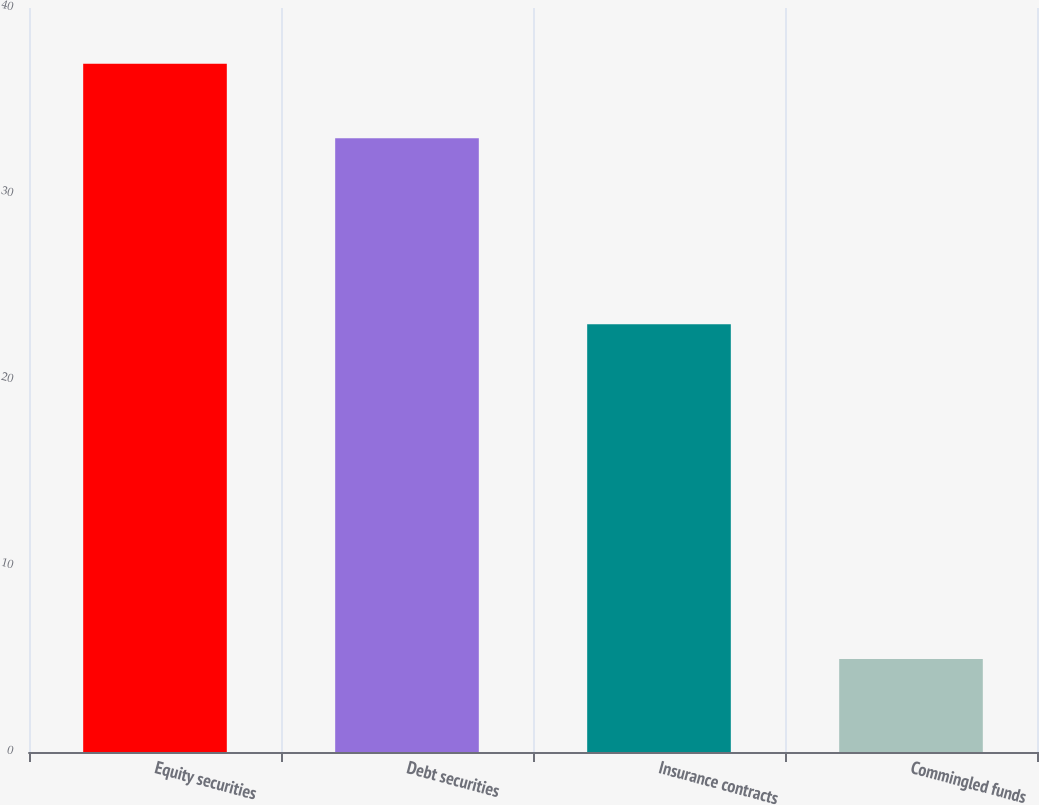Convert chart to OTSL. <chart><loc_0><loc_0><loc_500><loc_500><bar_chart><fcel>Equity securities<fcel>Debt securities<fcel>Insurance contracts<fcel>Commingled funds<nl><fcel>37<fcel>33<fcel>23<fcel>5<nl></chart> 